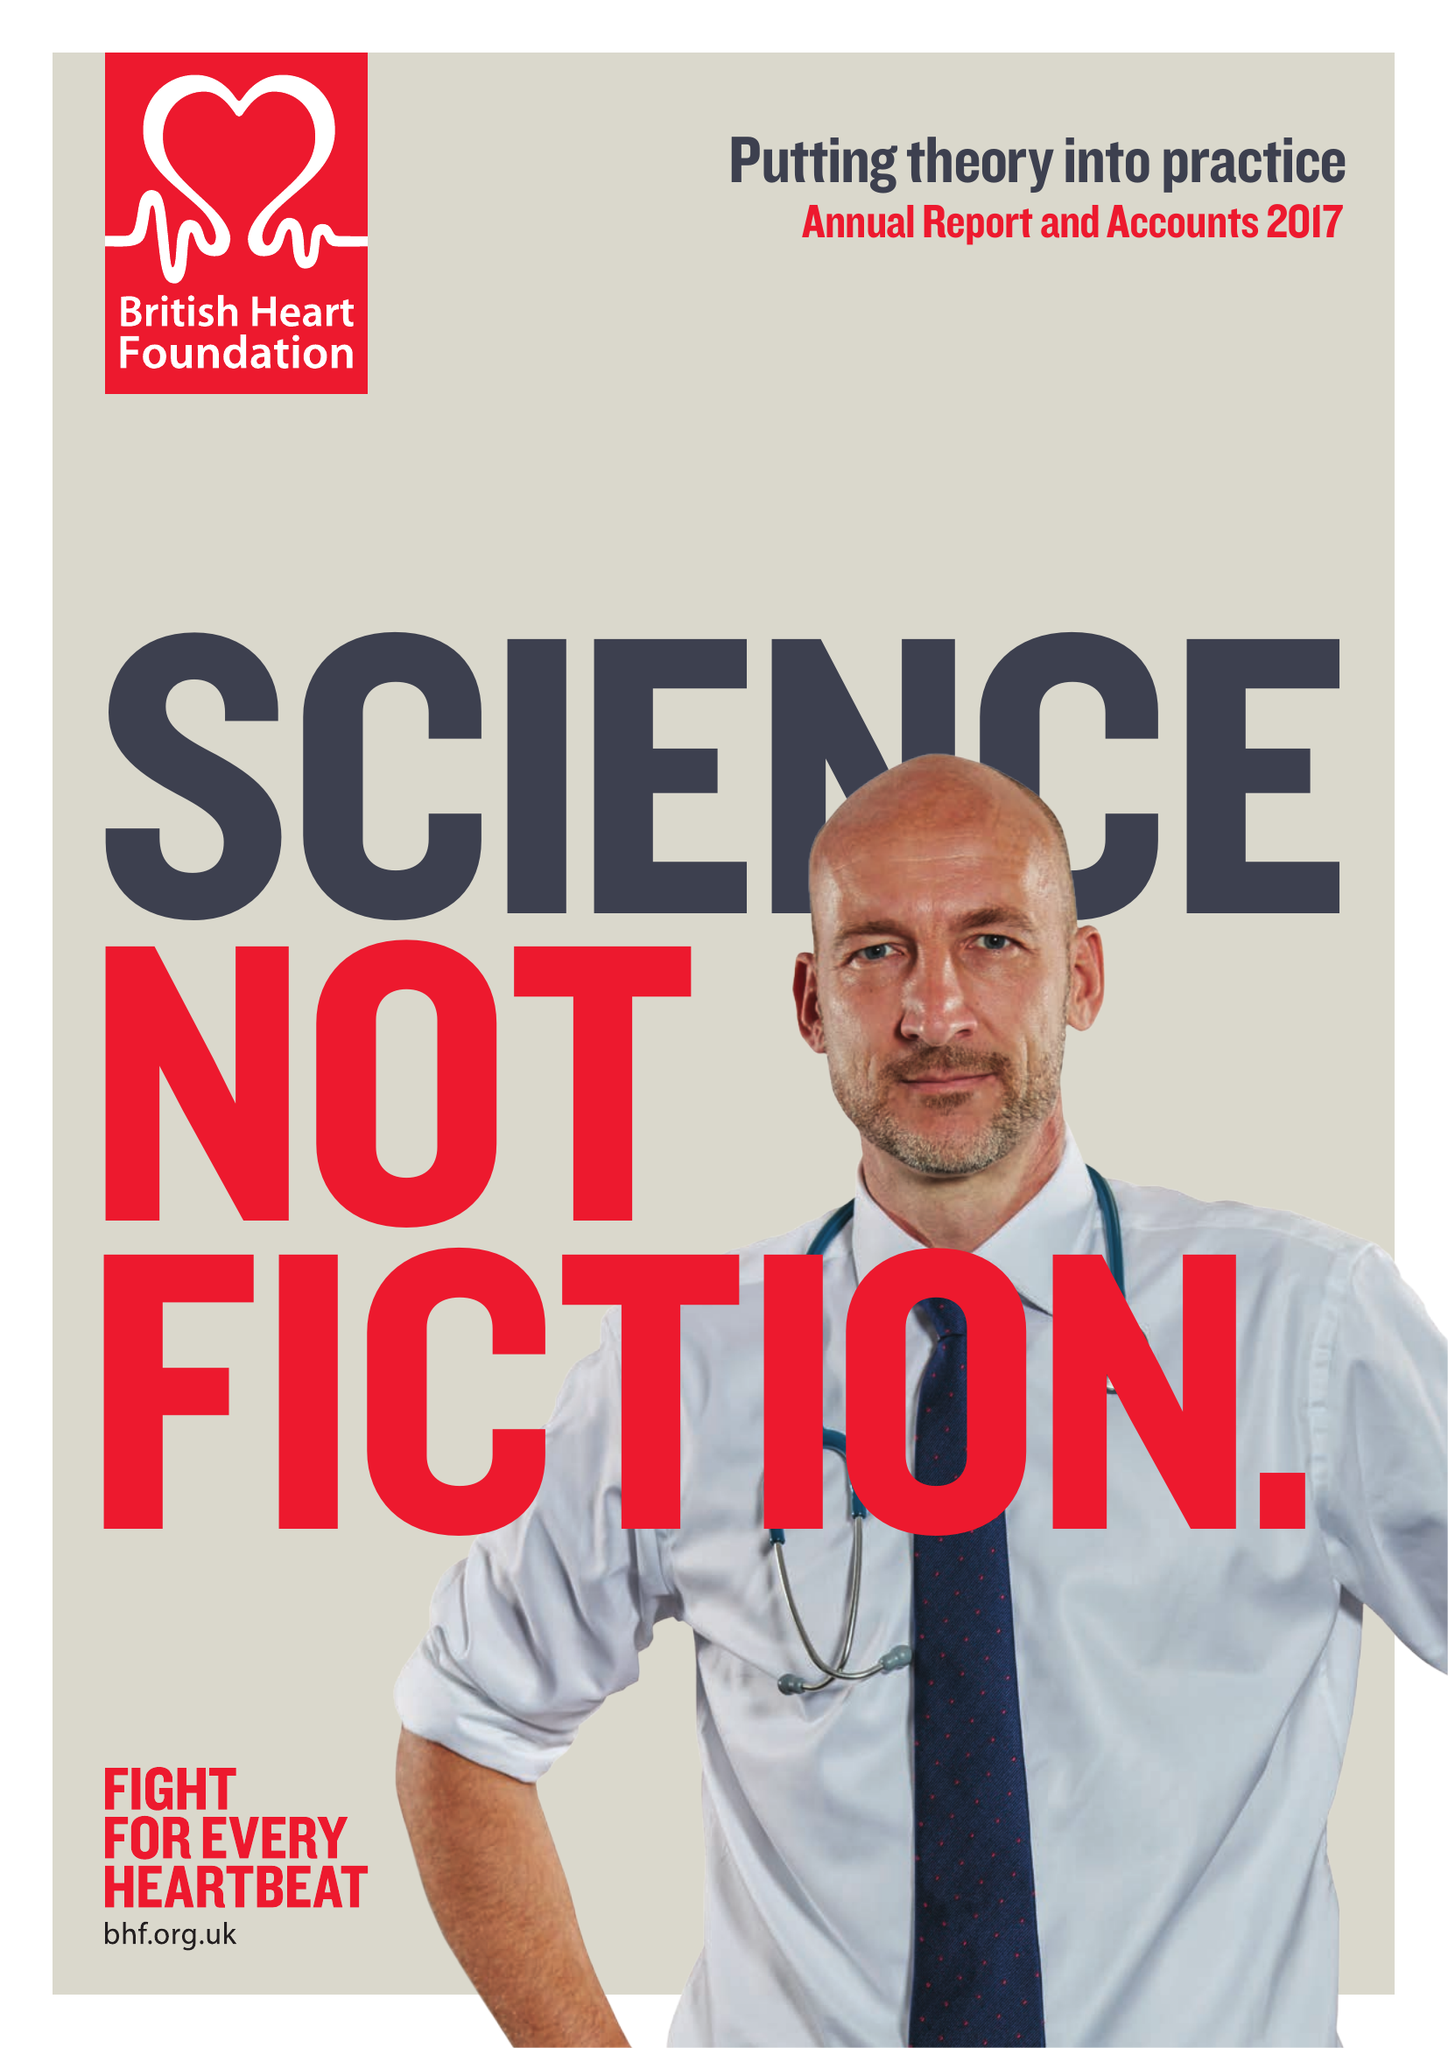What is the value for the income_annually_in_british_pounds?
Answer the question using a single word or phrase. 310500000.00 